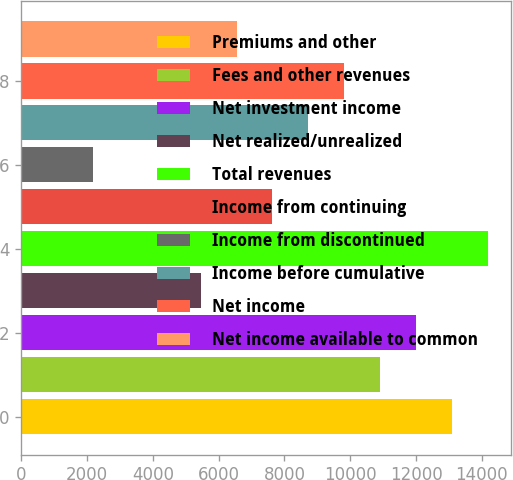Convert chart to OTSL. <chart><loc_0><loc_0><loc_500><loc_500><bar_chart><fcel>Premiums and other<fcel>Fees and other revenues<fcel>Net investment income<fcel>Net realized/unrealized<fcel>Total revenues<fcel>Income from continuing<fcel>Income from discontinued<fcel>Income before cumulative<fcel>Net income<fcel>Net income available to common<nl><fcel>13087.2<fcel>10906.5<fcel>11996.9<fcel>5454.76<fcel>14177.6<fcel>7635.46<fcel>2183.71<fcel>8725.81<fcel>9816.16<fcel>6545.11<nl></chart> 